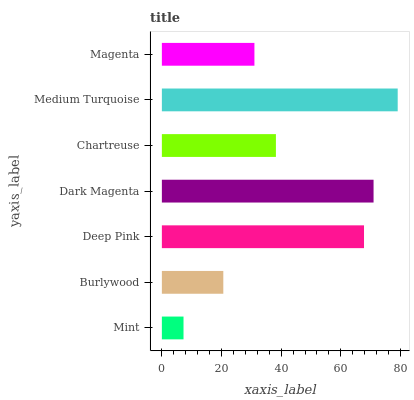Is Mint the minimum?
Answer yes or no. Yes. Is Medium Turquoise the maximum?
Answer yes or no. Yes. Is Burlywood the minimum?
Answer yes or no. No. Is Burlywood the maximum?
Answer yes or no. No. Is Burlywood greater than Mint?
Answer yes or no. Yes. Is Mint less than Burlywood?
Answer yes or no. Yes. Is Mint greater than Burlywood?
Answer yes or no. No. Is Burlywood less than Mint?
Answer yes or no. No. Is Chartreuse the high median?
Answer yes or no. Yes. Is Chartreuse the low median?
Answer yes or no. Yes. Is Burlywood the high median?
Answer yes or no. No. Is Dark Magenta the low median?
Answer yes or no. No. 